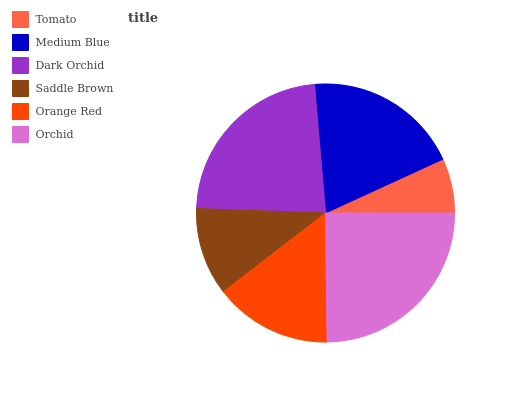Is Tomato the minimum?
Answer yes or no. Yes. Is Orchid the maximum?
Answer yes or no. Yes. Is Medium Blue the minimum?
Answer yes or no. No. Is Medium Blue the maximum?
Answer yes or no. No. Is Medium Blue greater than Tomato?
Answer yes or no. Yes. Is Tomato less than Medium Blue?
Answer yes or no. Yes. Is Tomato greater than Medium Blue?
Answer yes or no. No. Is Medium Blue less than Tomato?
Answer yes or no. No. Is Medium Blue the high median?
Answer yes or no. Yes. Is Orange Red the low median?
Answer yes or no. Yes. Is Dark Orchid the high median?
Answer yes or no. No. Is Medium Blue the low median?
Answer yes or no. No. 